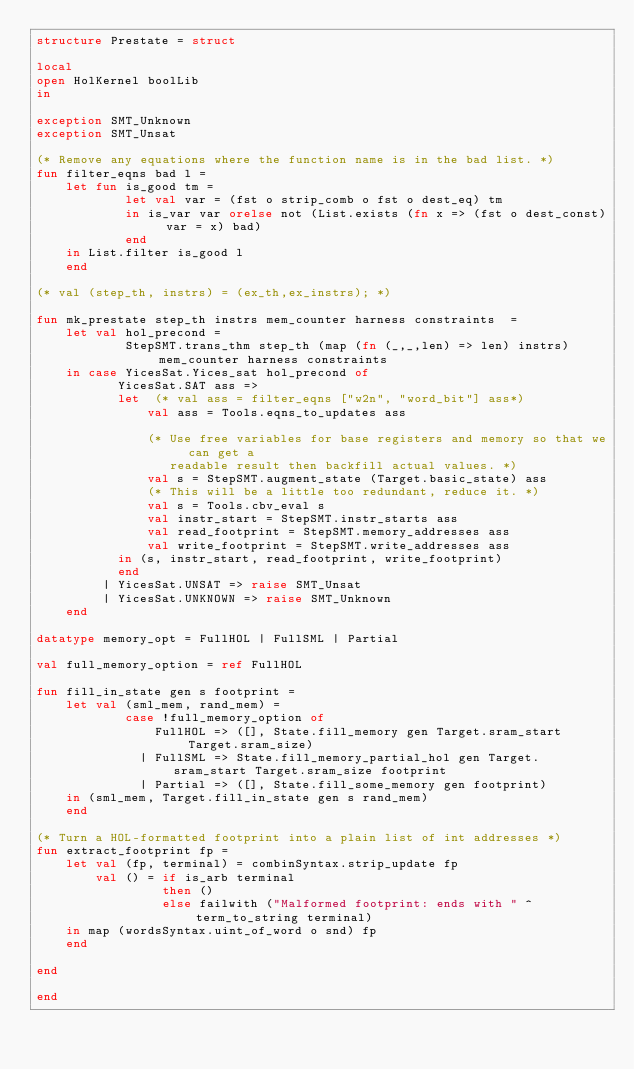<code> <loc_0><loc_0><loc_500><loc_500><_SML_>structure Prestate = struct

local
open HolKernel boolLib
in

exception SMT_Unknown
exception SMT_Unsat

(* Remove any equations where the function name is in the bad list. *)
fun filter_eqns bad l =
    let fun is_good tm =
            let val var = (fst o strip_comb o fst o dest_eq) tm
            in is_var var orelse not (List.exists (fn x => (fst o dest_const) var = x) bad)
            end
    in List.filter is_good l
    end

(* val (step_th, instrs) = (ex_th,ex_instrs); *)

fun mk_prestate step_th instrs mem_counter harness constraints  =
    let val hol_precond =
            StepSMT.trans_thm step_th (map (fn (_,_,len) => len) instrs) mem_counter harness constraints
    in case YicesSat.Yices_sat hol_precond of
           YicesSat.SAT ass =>
           let  (* val ass = filter_eqns ["w2n", "word_bit"] ass*)
               val ass = Tools.eqns_to_updates ass
                         
               (* Use free variables for base registers and memory so that we can get a
                  readable result then backfill actual values. *)
               val s = StepSMT.augment_state (Target.basic_state) ass
               (* This will be a little too redundant, reduce it. *)
               val s = Tools.cbv_eval s
               val instr_start = StepSMT.instr_starts ass
               val read_footprint = StepSMT.memory_addresses ass
               val write_footprint = StepSMT.write_addresses ass
           in (s, instr_start, read_footprint, write_footprint)
           end
         | YicesSat.UNSAT => raise SMT_Unsat
         | YicesSat.UNKNOWN => raise SMT_Unknown
    end

datatype memory_opt = FullHOL | FullSML | Partial

val full_memory_option = ref FullHOL

fun fill_in_state gen s footprint =
    let val (sml_mem, rand_mem) =
            case !full_memory_option of
                FullHOL => ([], State.fill_memory gen Target.sram_start Target.sram_size)
              | FullSML => State.fill_memory_partial_hol gen Target.sram_start Target.sram_size footprint
              | Partial => ([], State.fill_some_memory gen footprint)
    in (sml_mem, Target.fill_in_state gen s rand_mem)
    end

(* Turn a HOL-formatted footprint into a plain list of int addresses *)
fun extract_footprint fp =
    let val (fp, terminal) = combinSyntax.strip_update fp
        val () = if is_arb terminal
                 then ()
                 else failwith ("Malformed footprint: ends with " ^ term_to_string terminal)
    in map (wordsSyntax.uint_of_word o snd) fp
    end

end

end
</code> 